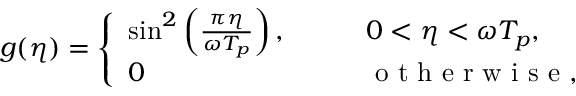Convert formula to latex. <formula><loc_0><loc_0><loc_500><loc_500>g ( \eta ) = \left \{ \begin{array} { l l } { \sin ^ { 2 } \left ( \frac { \pi \eta } { \omega T _ { p } } \right ) , \quad } & { 0 < \eta < \omega T _ { p } , } \\ { 0 } & { o t h e r w i s e , } \end{array}</formula> 